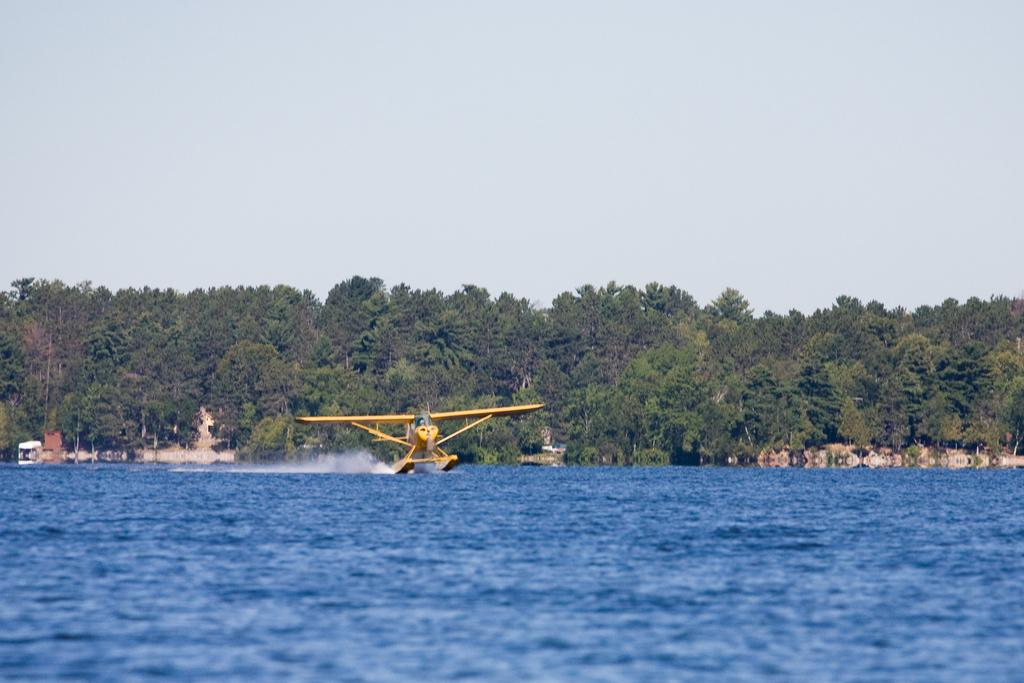What is the main subject of the image? The main subject of the image is a yellow aircraft. What is the aircraft doing in the image? The aircraft is flying over the water in the image. What can be seen in the background of the image? There are trees and the sky visible in the background of the image. What type of loaf is being used as a flotation device for the aircraft in the image? There is no loaf present in the image, and the aircraft is not using any flotation device. 